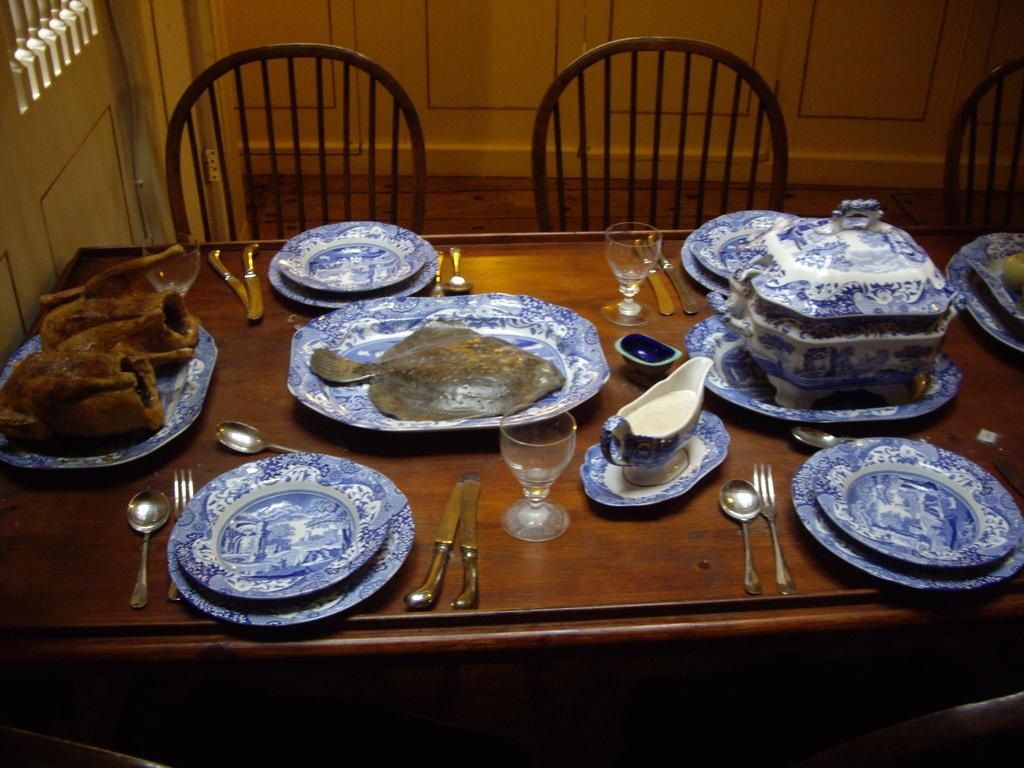What piece of furniture is present in the image? There is a table in the image. What utensils can be seen on the table? There is a spoon, a fork, and knives on the table. What type of dishware is present on the table? There is a glass and a plate with food on the table. What other items are on the table? There are dishes on the table. What is near the table? There are chairs near the table. What architectural features can be seen in the image? There is a door and a wall in the image. What type of wrist accessory is visible on the table in the image? There is no wrist accessory present on the table in the image. Is there any sleet visible through the door in the image? There is no mention of sleet or any weather conditions in the image; it only shows a table, utensils, dishware, and architectural features. 